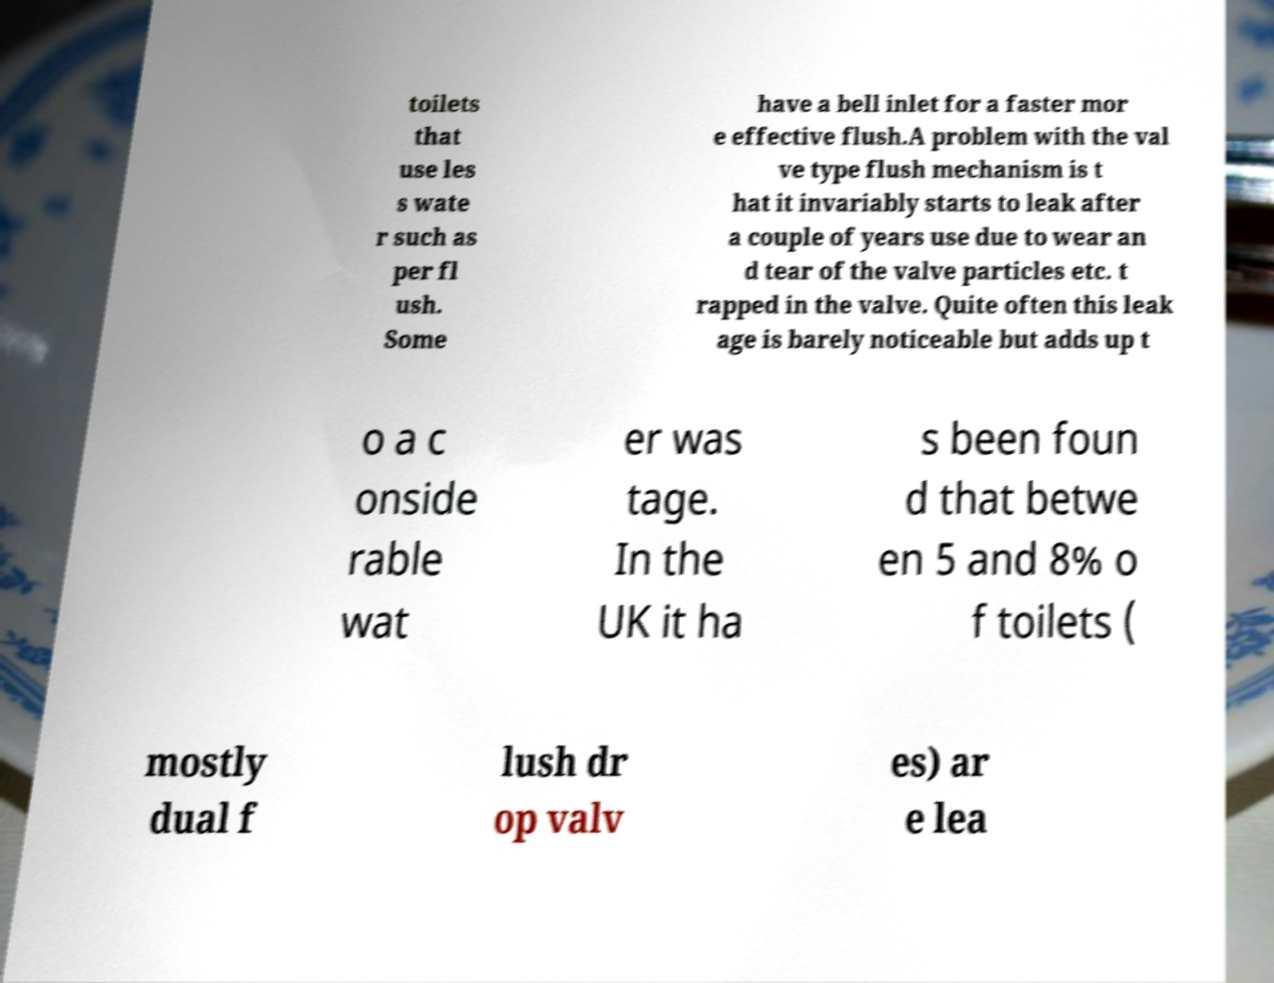Please read and relay the text visible in this image. What does it say? toilets that use les s wate r such as per fl ush. Some have a bell inlet for a faster mor e effective flush.A problem with the val ve type flush mechanism is t hat it invariably starts to leak after a couple of years use due to wear an d tear of the valve particles etc. t rapped in the valve. Quite often this leak age is barely noticeable but adds up t o a c onside rable wat er was tage. In the UK it ha s been foun d that betwe en 5 and 8% o f toilets ( mostly dual f lush dr op valv es) ar e lea 